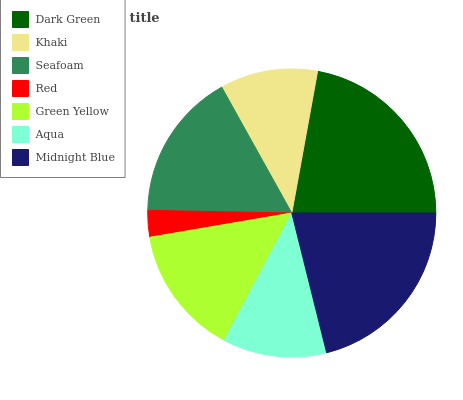Is Red the minimum?
Answer yes or no. Yes. Is Dark Green the maximum?
Answer yes or no. Yes. Is Khaki the minimum?
Answer yes or no. No. Is Khaki the maximum?
Answer yes or no. No. Is Dark Green greater than Khaki?
Answer yes or no. Yes. Is Khaki less than Dark Green?
Answer yes or no. Yes. Is Khaki greater than Dark Green?
Answer yes or no. No. Is Dark Green less than Khaki?
Answer yes or no. No. Is Green Yellow the high median?
Answer yes or no. Yes. Is Green Yellow the low median?
Answer yes or no. Yes. Is Dark Green the high median?
Answer yes or no. No. Is Seafoam the low median?
Answer yes or no. No. 